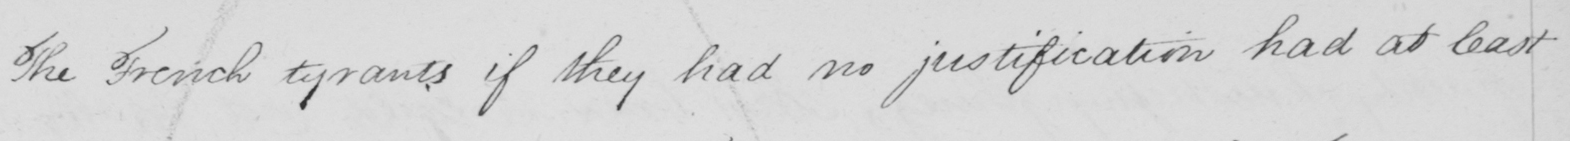What text is written in this handwritten line? The French tyrants if they had no justification had at least 